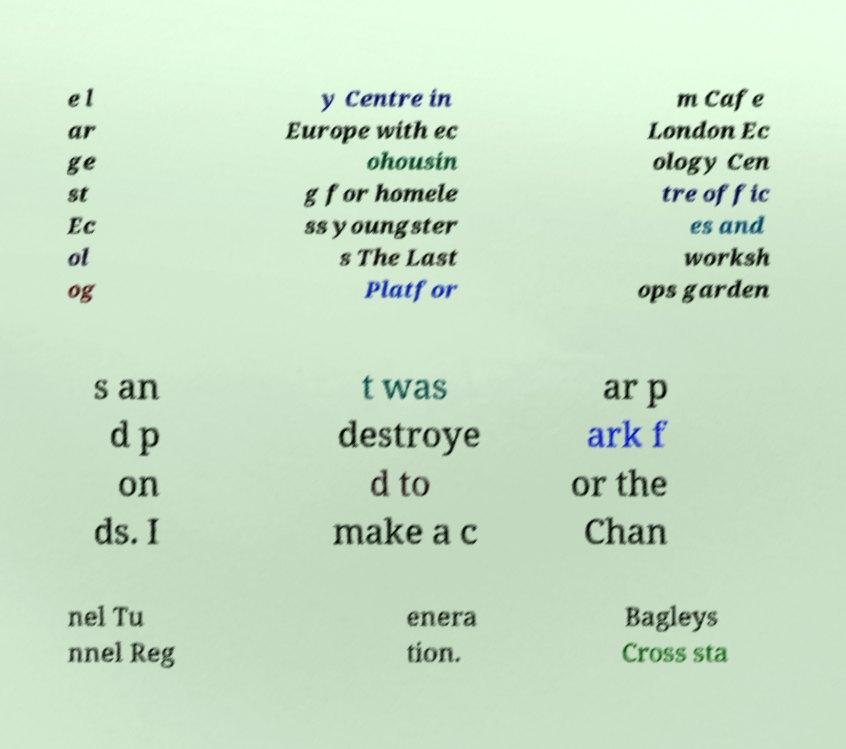For documentation purposes, I need the text within this image transcribed. Could you provide that? e l ar ge st Ec ol og y Centre in Europe with ec ohousin g for homele ss youngster s The Last Platfor m Cafe London Ec ology Cen tre offic es and worksh ops garden s an d p on ds. I t was destroye d to make a c ar p ark f or the Chan nel Tu nnel Reg enera tion. Bagleys Cross sta 